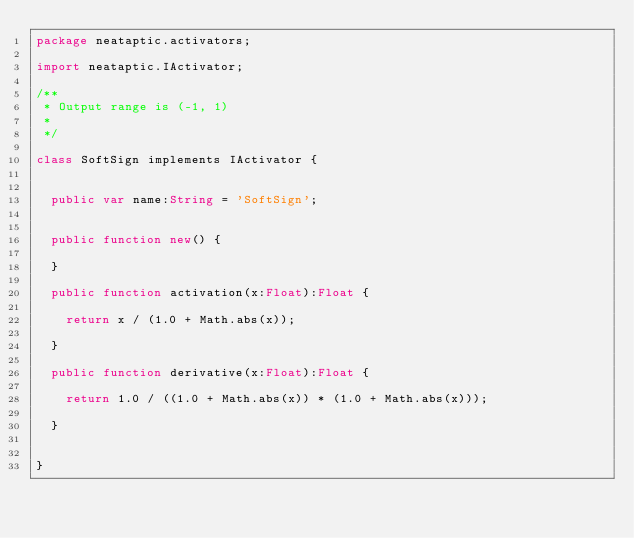<code> <loc_0><loc_0><loc_500><loc_500><_Haxe_>package neataptic.activators;

import neataptic.IActivator;

/**
 * Output range is (-1, 1)
 * 
 */

class SoftSign implements IActivator {


	public var name:String = 'SoftSign';


	public function new() {
		
	}
	
	public function activation(x:Float):Float {

		return x / (1.0 + Math.abs(x));

	}
	
	public function derivative(x:Float):Float {

		return 1.0 / ((1.0 + Math.abs(x)) * (1.0 + Math.abs(x)));
		
	}


}</code> 